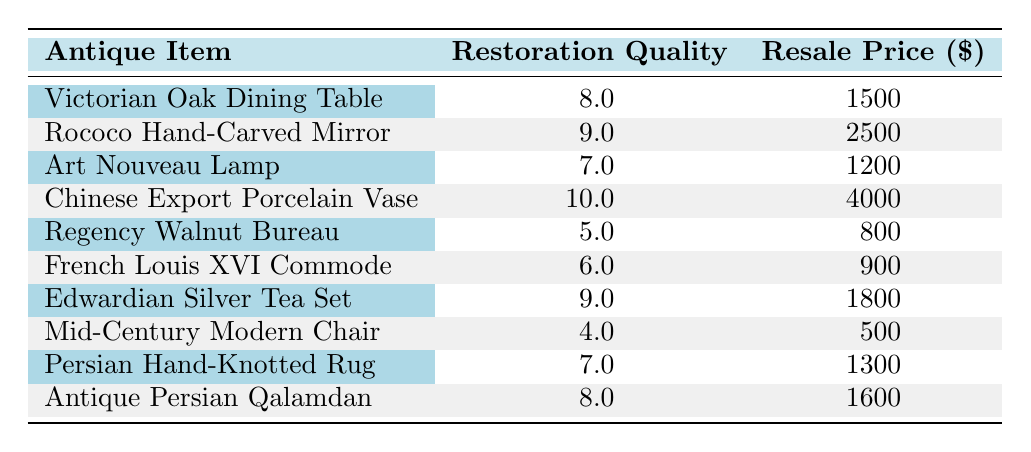What is the resale price of the Chinese Export Porcelain Vase? The resale price is listed directly next to the antique item in the table. For the Chinese Export Porcelain Vase, it shows $4000.
Answer: 4000 Which antique has the highest restoration quality? The antique with the highest restoration quality is identified by looking for the maximum value in the Restoration Quality column. The Chinese Export Porcelain Vase has a quality of 10.
Answer: Chinese Export Porcelain Vase What is the average resale price of antiques with a restoration quality of 8 or higher? Identify the antiques with a restoration quality of 8 or higher: Victorian Oak Dining Table ($1500), Rococo Hand-Carved Mirror ($2500), Chinese Export Porcelain Vase ($4000), Edwardian Silver Tea Set ($1800), and Antique Persian Qalamdan ($1600). The sum of their prices is 1500 + 2500 + 4000 + 1800 + 1600 = 11400. There are 5 antiques, so the average is 11400 / 5 = 2280.
Answer: 2280 Is there any antique with a resale price less than $800? By inspecting the Resale Price column, it can be seen that the lowest price listed is $500 for the Mid-Century Modern Chair. Since an item exists below $800, the answer is yes.
Answer: Yes How much more does the Rococo Hand-Carved Mirror sell for compared to the Mid-Century Modern Chair? The resale price of the Rococo Hand-Carved Mirror is $2500, and the resale price of the Mid-Century Modern Chair is $500. The difference is calculated as 2500 - 500 = 2000.
Answer: 2000 What is the total resale price of all antiques with a restoration quality of 6 or lower? The antiques with a restoration quality of 6 or lower are: Regency Walnut Bureau ($800), French Louis XVI Commode ($900), and Mid-Century Modern Chair ($500). Adding these together gives 800 + 900 + 500 = 2200.
Answer: 2200 Are there any antiques that have the same restoration quality value? Checking the Restoration Quality column reveals two antiques, the Victorian Oak Dining Table and the Antique Persian Qalamdan, both with a quality of 8. Therefore, the answer is yes.
Answer: Yes What is the highest resale price among items with a restoration quality of 7 or lower? The antiques with a restoration quality of 7 or lower are the Art Nouveau Lamp ($1200), the Regency Walnut Bureau ($800), the French Louis XVI Commode ($900), and the Mid-Century Modern Chair ($500). The highest price among these is $1200 for the Art Nouveau Lamp.
Answer: 1200 What percentage of antiques have a resale price above $2000? There are 10 antiques in total; the ones with a resale price above $2000 are: Rococo Hand-Carved Mirror ($2500) and Chinese Export Porcelain Vase ($4000), totaling 2 items. The percentage is (2/10) * 100 = 20%.
Answer: 20% 